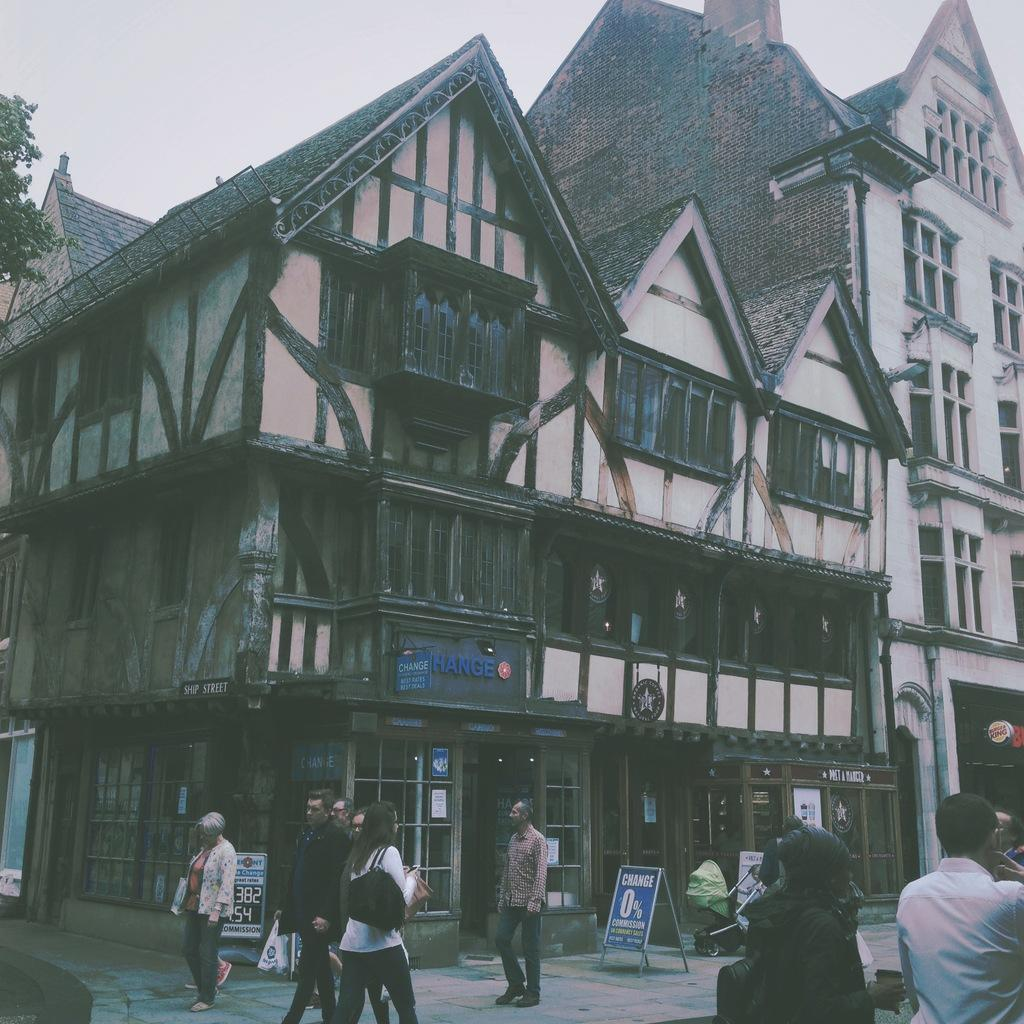Who or what can be seen in the image? There are people in the image. What is hanging or displayed in the image? There is a banner in the image. What type of structures are visible in the image? There are buildings in the image. What type of vegetation is present in the image? There is a tree in the image. What is visible at the top of the image? The sky is visible at the top of the image. Where is the sofa located in the image? There is no sofa present in the image. What type of soap is being used by the people in the image? There is no soap visible in the image, and it is not mentioned that the people are using soap. 